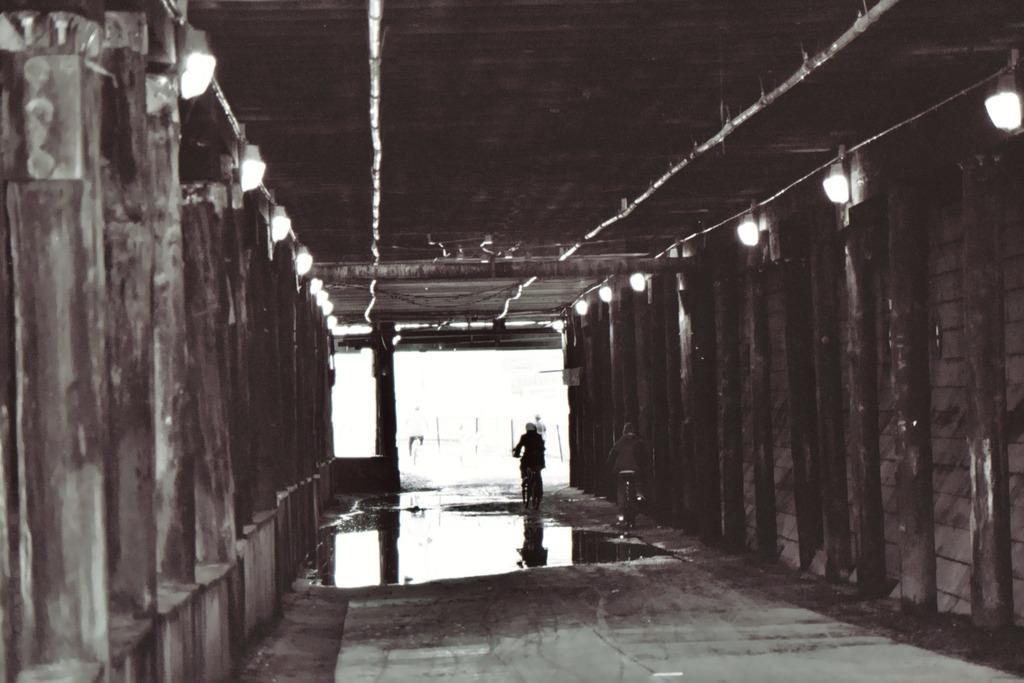Could you give a brief overview of what you see in this image? In the middle of the image we can see two persons riding on the bicycles. On the left and right sides of the image we can see wooden fence and lights attached to them. 